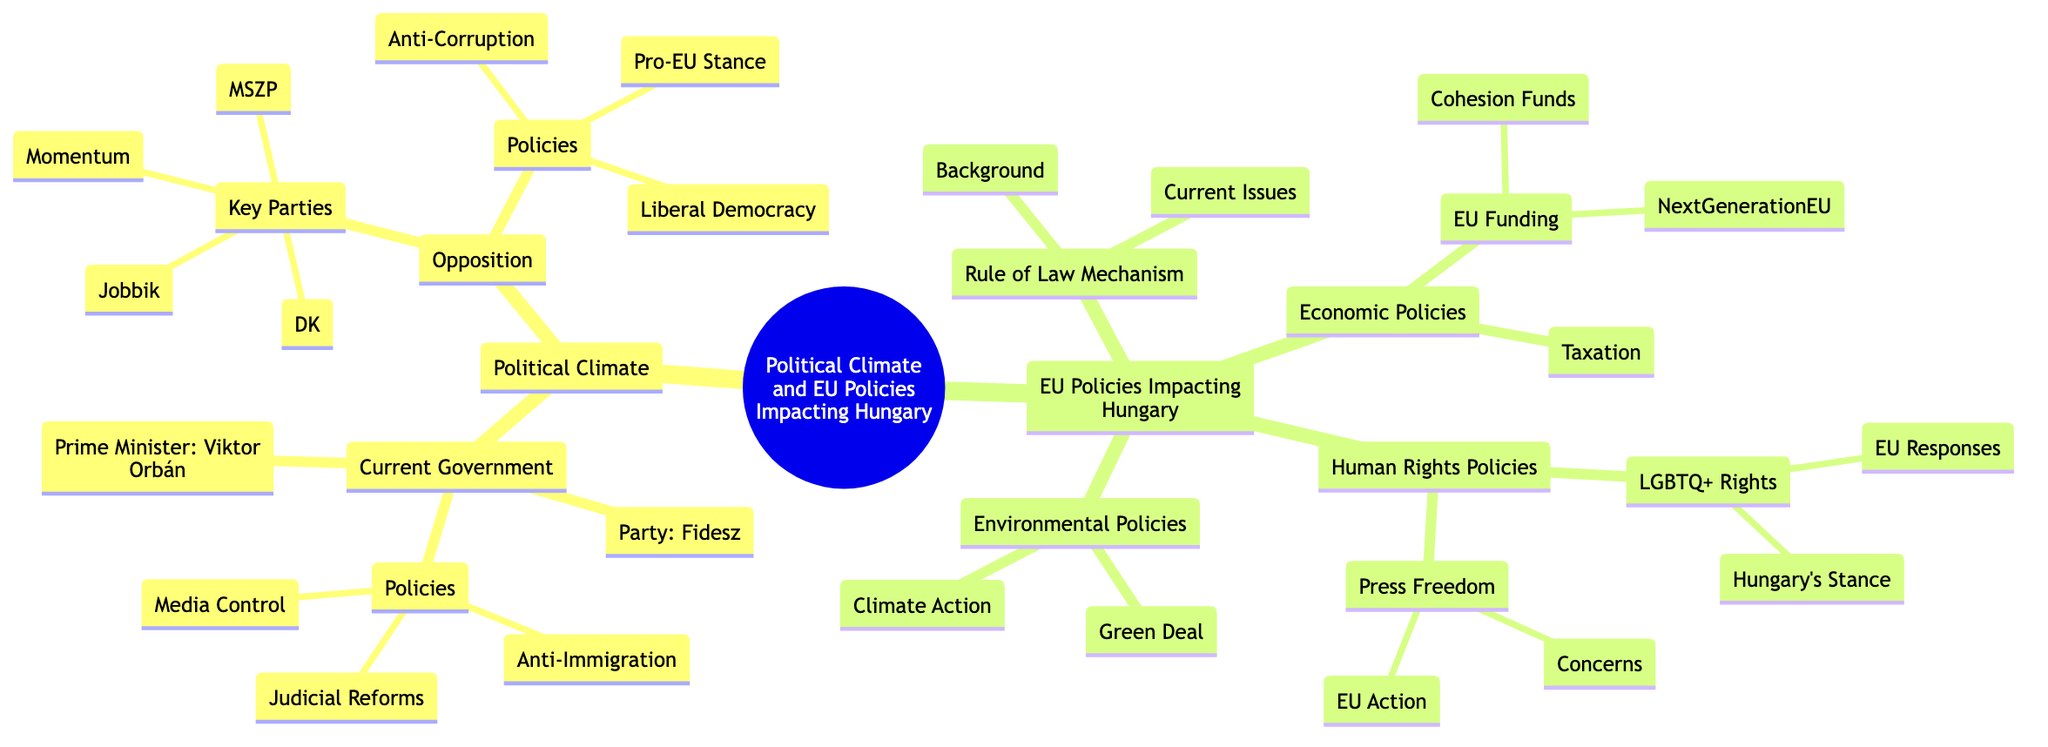What is the name of the current Prime Minister of Hungary? The diagram states that the current Prime Minister is Viktor Orbán.
Answer: Viktor Orbán Which political party does the current government belong to? According to the diagram, the current government is from the Fidesz – Hungarian Civic Alliance.
Answer: Fidesz – Hungarian Civic Alliance What is one of the key opposition parties listed in the diagram? The diagram lists several key parties under opposition, and one of them is the Hungarian Socialist Party (MSZP).
Answer: Hungarian Socialist Party (MSZP) What does the Rule of Law Mechanism address according to the diagram? The diagram indicates that the Rule of Law Mechanism is a tool used by the EU to ensure compliance with democratic principles.
Answer: Compliance with democratic principles How many key opposition parties are identified in the diagram? The diagram shows four key opposition parties: Hungarian Socialist Party, Democratic Coalition, Jobbik, and Momentum Movement, totaling four parties.
Answer: 4 What is one of the current issues related to the Rule of Law Mechanism? The diagram specifies that potential sanctions and funding cuts for Hungary are a current issue concerning the Rule of Law Mechanism.
Answer: Potential sanctions and funding cuts What policy is highlighted under the EU's Human Rights Policies regarding LGBTQ+ rights? According to the diagram, Hungary's stance on LGBTQ+ rights includes anti-LGBTQ+ laws and policies.
Answer: Anti-LGBTQ+ laws and policies Which EU policy aims to provide financial support for regional development? The diagram states that Cohesion Funds are part of the EU funding policy for regional development.
Answer: Cohesion Funds What environmental initiative belongs to the EU policies impacting Hungary? The diagram mentions the European Green Deal as an environmental initiative affecting Hungary.
Answer: European Green Deal What type of reforms are linked to the current government in Hungary? The diagram shows that the current government has implemented controversial changes to judiciary independence as part of its reforms.
Answer: Controversial changes to judiciary independence 